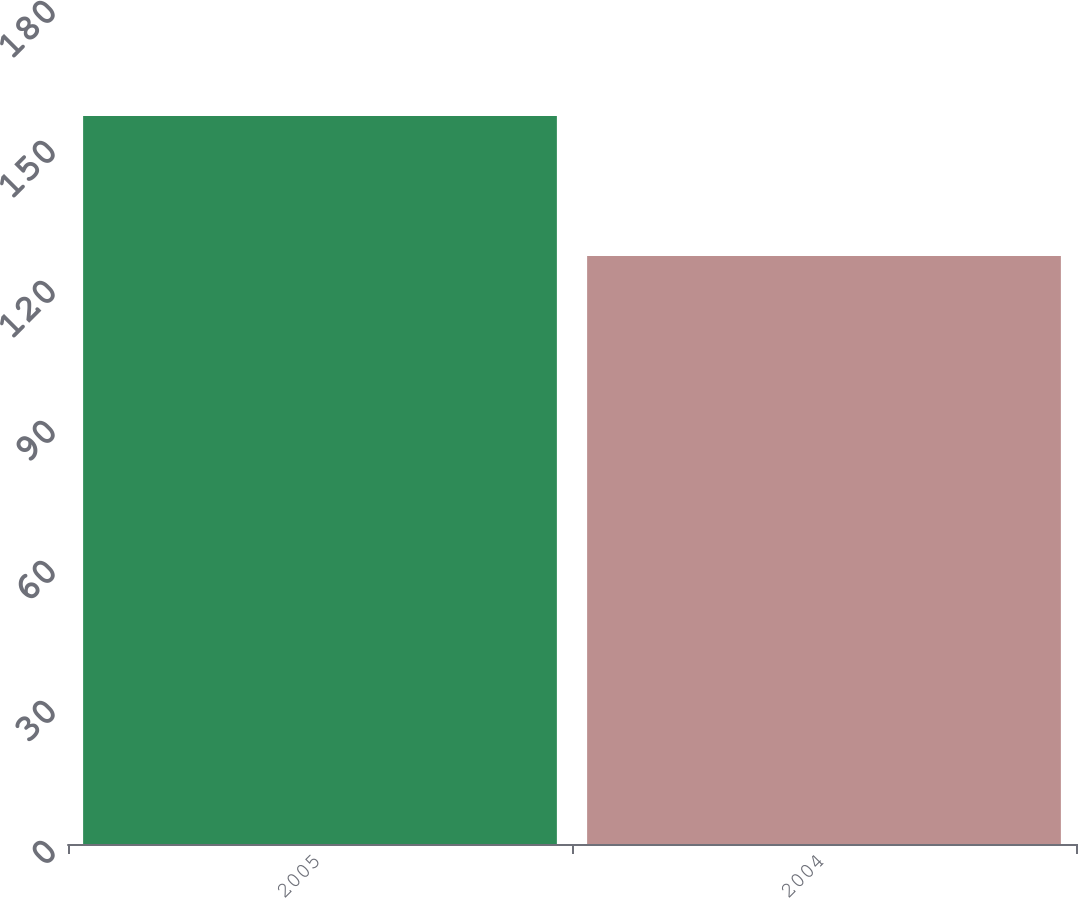Convert chart to OTSL. <chart><loc_0><loc_0><loc_500><loc_500><bar_chart><fcel>2005<fcel>2004<nl><fcel>156<fcel>126<nl></chart> 